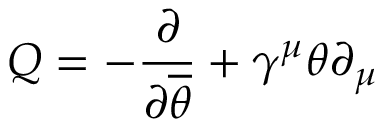Convert formula to latex. <formula><loc_0><loc_0><loc_500><loc_500>Q = - { \frac { \partial } { \partial { \overline { \theta } } } } + \gamma ^ { \mu } \theta \partial _ { \mu }</formula> 